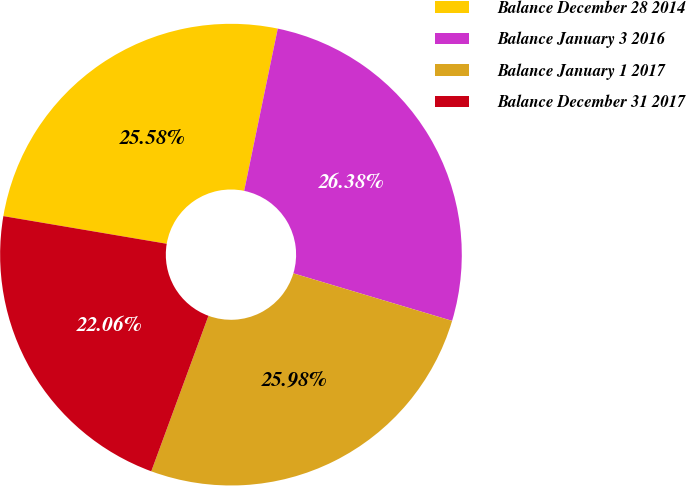Convert chart. <chart><loc_0><loc_0><loc_500><loc_500><pie_chart><fcel>Balance December 28 2014<fcel>Balance January 3 2016<fcel>Balance January 1 2017<fcel>Balance December 31 2017<nl><fcel>25.58%<fcel>26.38%<fcel>25.98%<fcel>22.06%<nl></chart> 